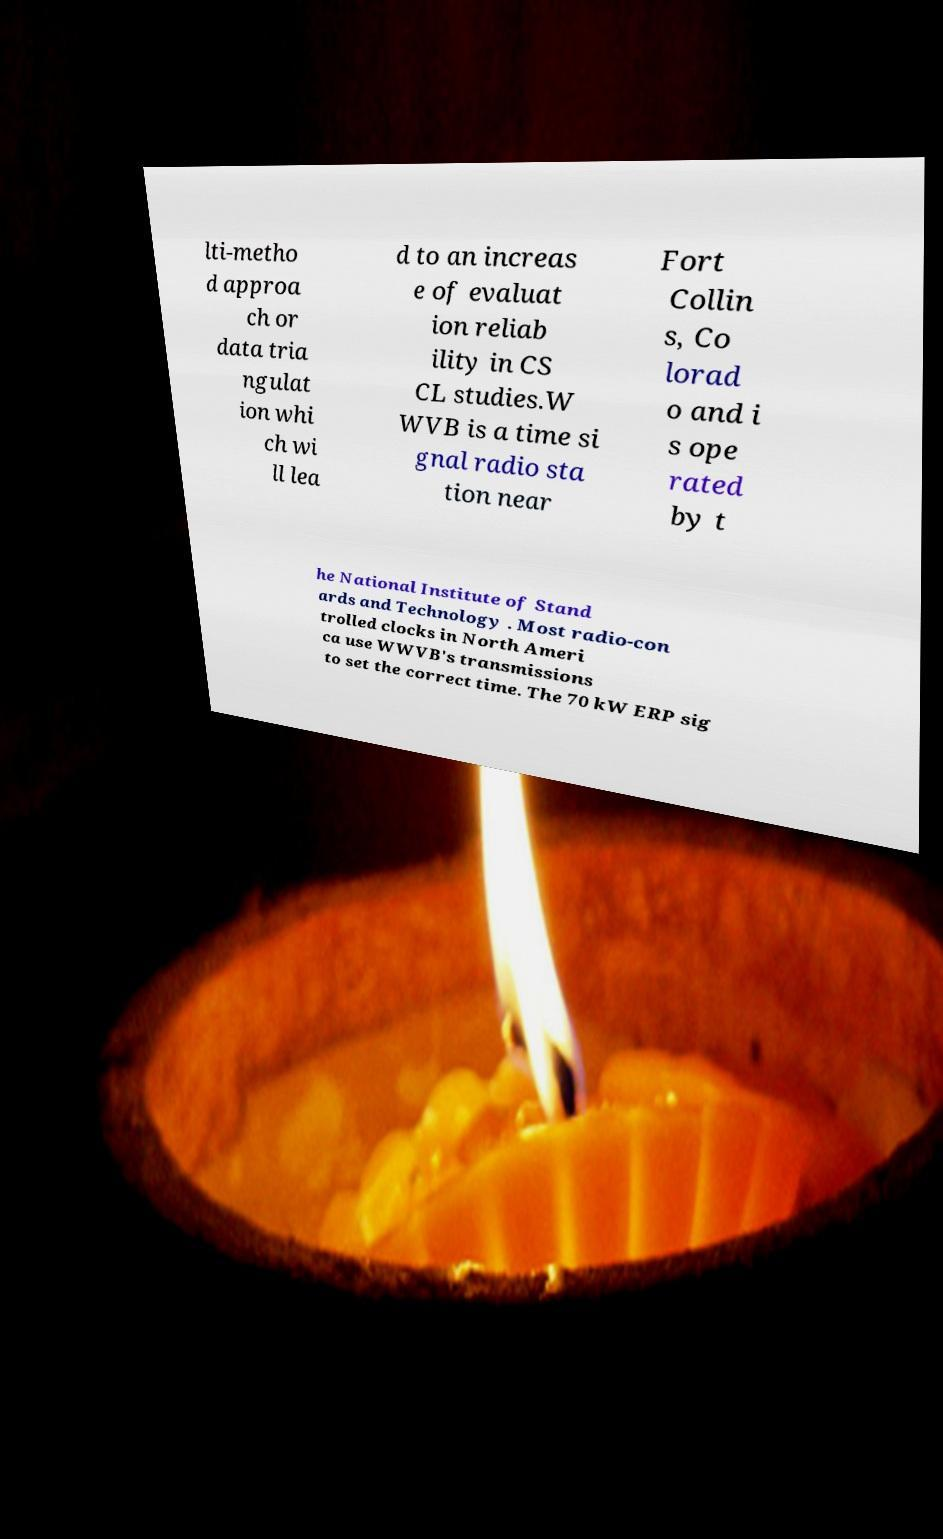Can you accurately transcribe the text from the provided image for me? lti-metho d approa ch or data tria ngulat ion whi ch wi ll lea d to an increas e of evaluat ion reliab ility in CS CL studies.W WVB is a time si gnal radio sta tion near Fort Collin s, Co lorad o and i s ope rated by t he National Institute of Stand ards and Technology . Most radio-con trolled clocks in North Ameri ca use WWVB's transmissions to set the correct time. The 70 kW ERP sig 